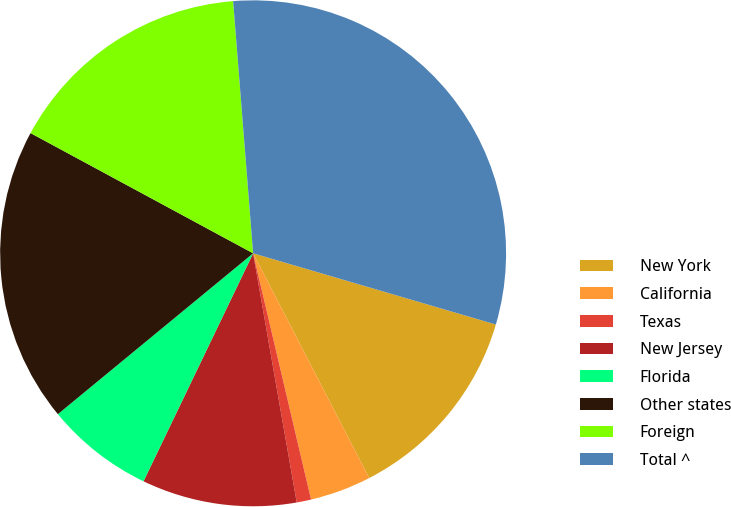<chart> <loc_0><loc_0><loc_500><loc_500><pie_chart><fcel>New York<fcel>California<fcel>Texas<fcel>New Jersey<fcel>Florida<fcel>Other states<fcel>Foreign<fcel>Total ^<nl><fcel>12.87%<fcel>3.91%<fcel>0.92%<fcel>9.89%<fcel>6.9%<fcel>18.85%<fcel>15.86%<fcel>30.8%<nl></chart> 